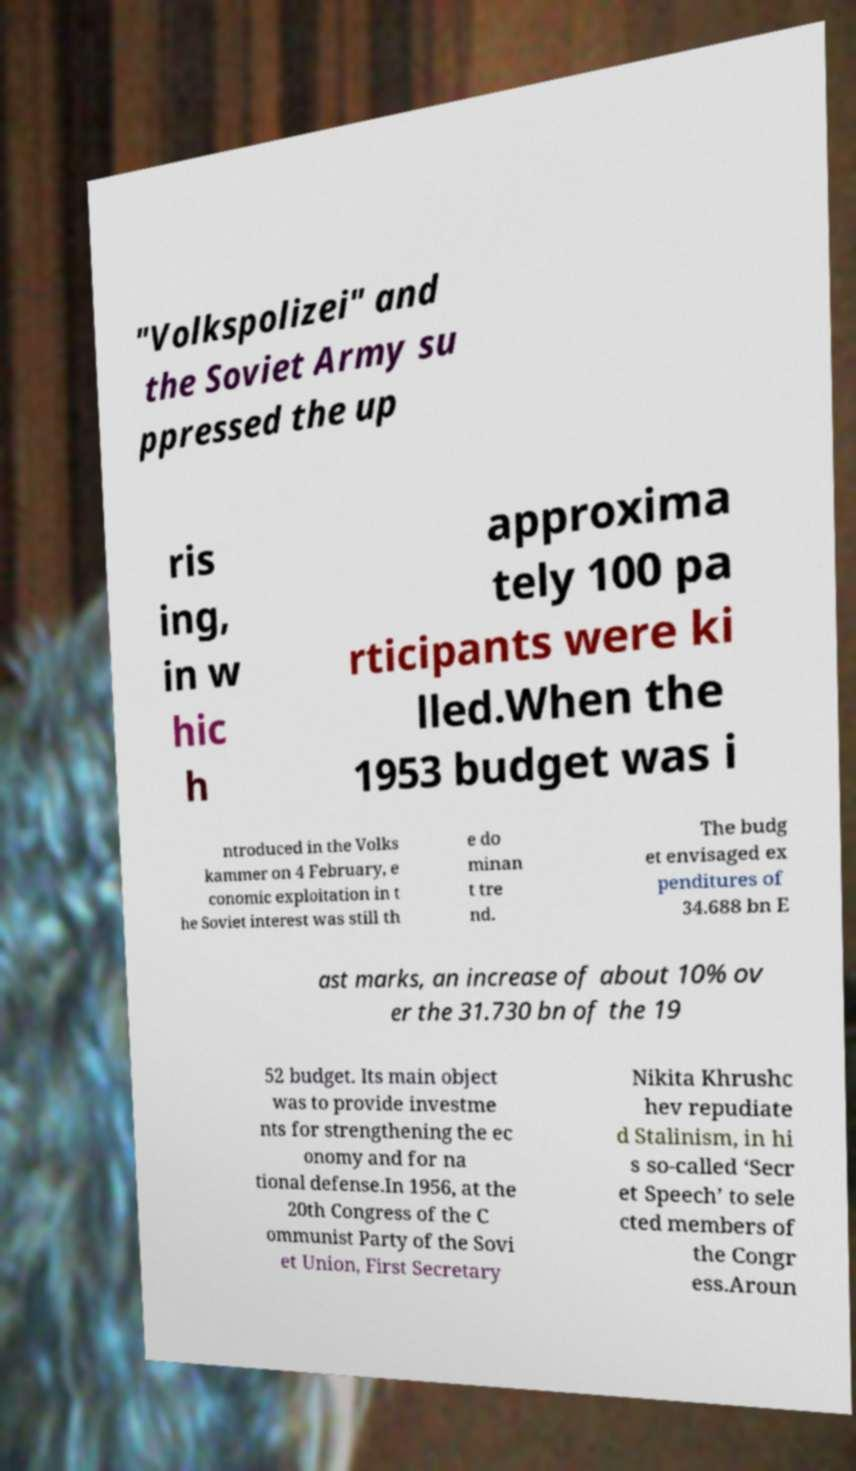Could you assist in decoding the text presented in this image and type it out clearly? "Volkspolizei" and the Soviet Army su ppressed the up ris ing, in w hic h approxima tely 100 pa rticipants were ki lled.When the 1953 budget was i ntroduced in the Volks kammer on 4 February, e conomic exploitation in t he Soviet interest was still th e do minan t tre nd. The budg et envisaged ex penditures of 34.688 bn E ast marks, an increase of about 10% ov er the 31.730 bn of the 19 52 budget. Its main object was to provide investme nts for strengthening the ec onomy and for na tional defense.In 1956, at the 20th Congress of the C ommunist Party of the Sovi et Union, First Secretary Nikita Khrushc hev repudiate d Stalinism, in hi s so-called ‘Secr et Speech’ to sele cted members of the Congr ess.Aroun 